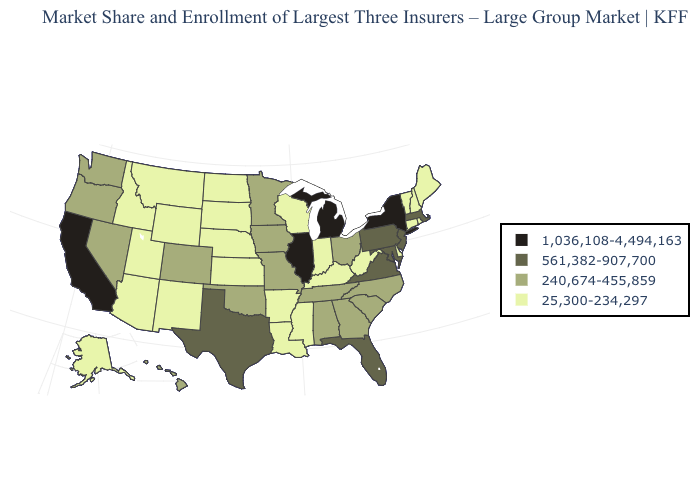What is the highest value in states that border South Carolina?
Short answer required. 240,674-455,859. What is the value of Kansas?
Answer briefly. 25,300-234,297. Among the states that border Connecticut , does Massachusetts have the lowest value?
Quick response, please. No. What is the value of Michigan?
Keep it brief. 1,036,108-4,494,163. What is the highest value in the USA?
Keep it brief. 1,036,108-4,494,163. Among the states that border Wyoming , which have the lowest value?
Write a very short answer. Idaho, Montana, Nebraska, South Dakota, Utah. Which states have the highest value in the USA?
Keep it brief. California, Illinois, Michigan, New York. Name the states that have a value in the range 1,036,108-4,494,163?
Be succinct. California, Illinois, Michigan, New York. Which states have the highest value in the USA?
Concise answer only. California, Illinois, Michigan, New York. What is the highest value in the USA?
Give a very brief answer. 1,036,108-4,494,163. Which states have the lowest value in the Northeast?
Answer briefly. Connecticut, Maine, New Hampshire, Rhode Island, Vermont. What is the value of Montana?
Give a very brief answer. 25,300-234,297. What is the value of New Hampshire?
Quick response, please. 25,300-234,297. Among the states that border Connecticut , does Rhode Island have the lowest value?
Concise answer only. Yes. Which states have the lowest value in the Northeast?
Give a very brief answer. Connecticut, Maine, New Hampshire, Rhode Island, Vermont. 